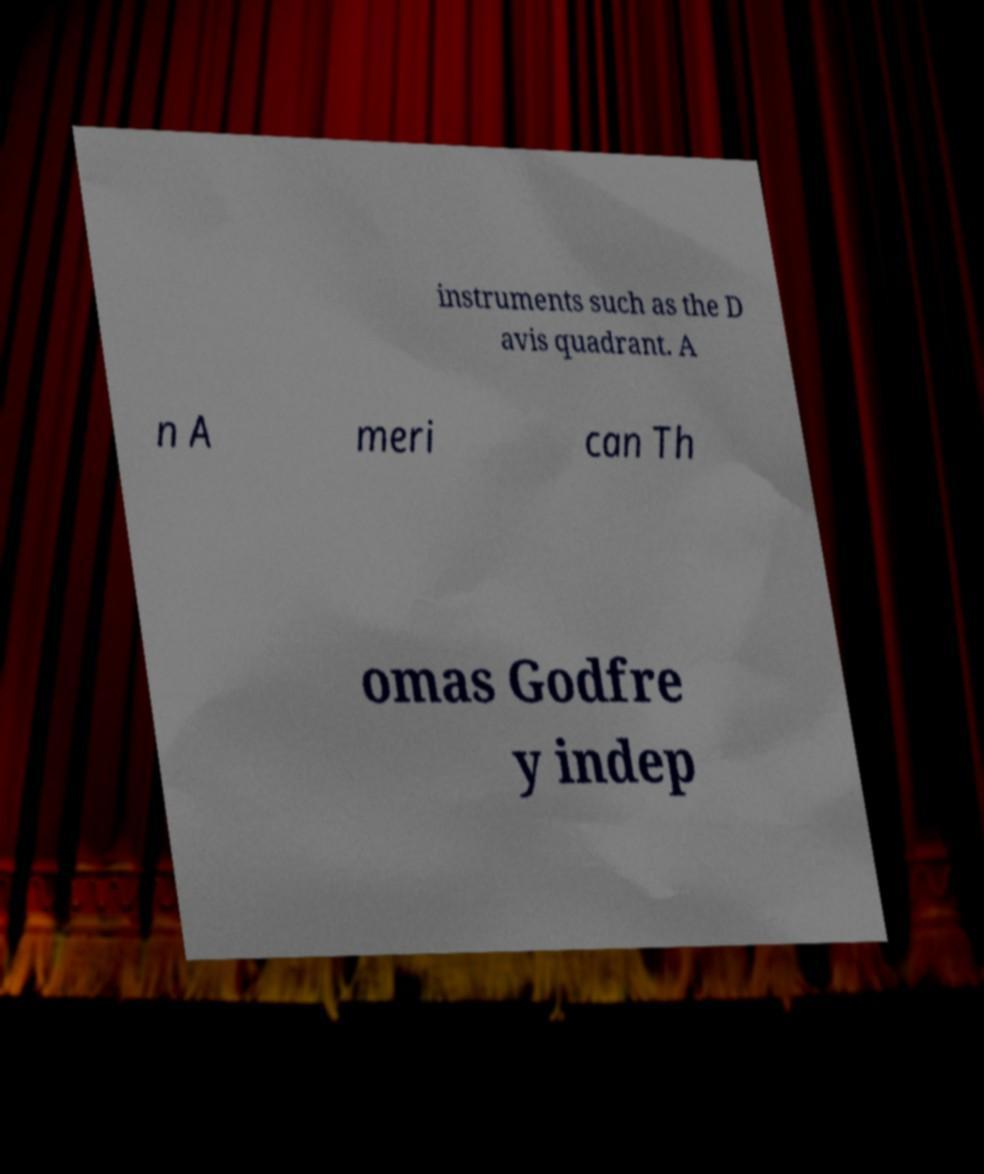Can you read and provide the text displayed in the image?This photo seems to have some interesting text. Can you extract and type it out for me? instruments such as the D avis quadrant. A n A meri can Th omas Godfre y indep 